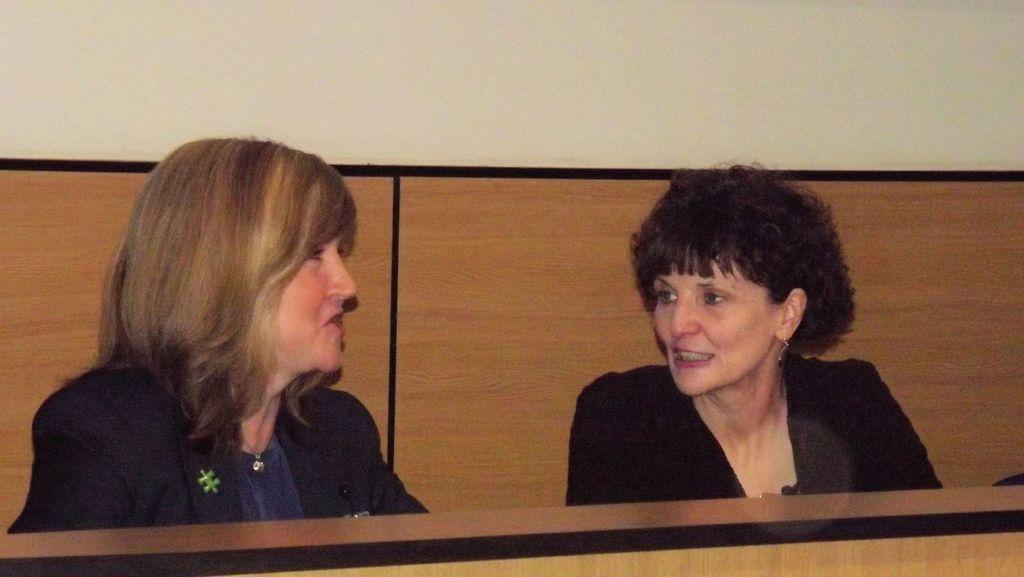How would you summarize this image in a sentence or two? In this image there are two persons sitting and smiling. 